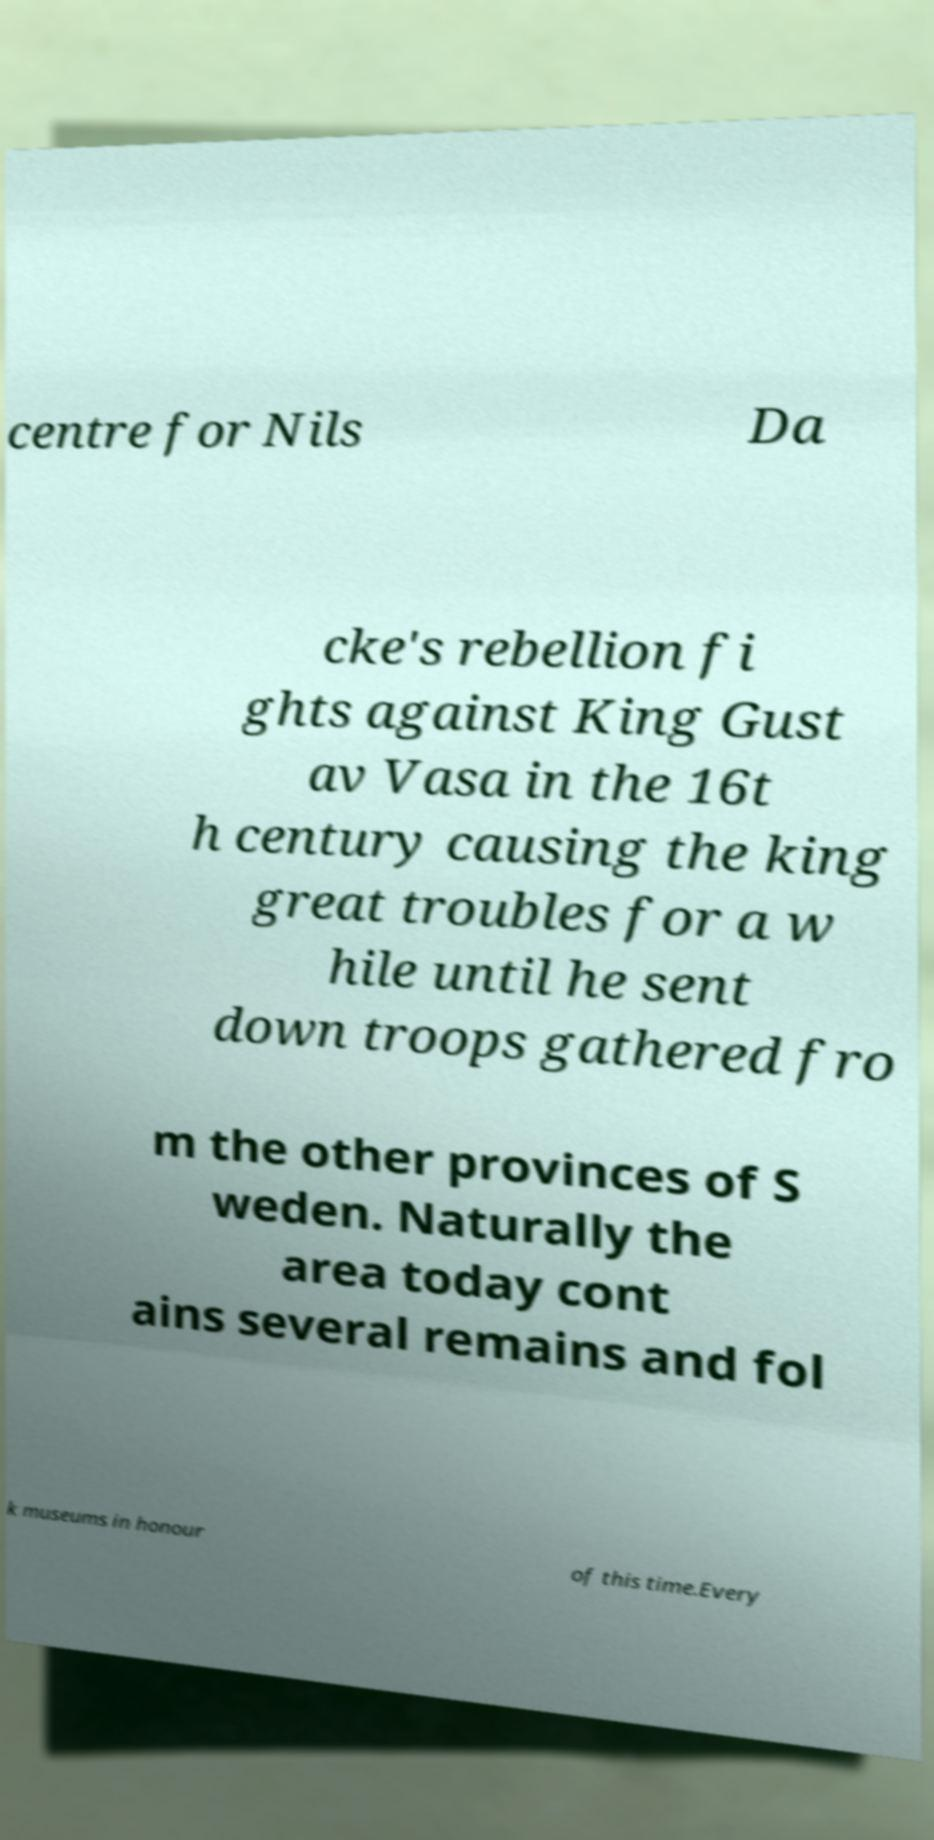There's text embedded in this image that I need extracted. Can you transcribe it verbatim? centre for Nils Da cke's rebellion fi ghts against King Gust av Vasa in the 16t h century causing the king great troubles for a w hile until he sent down troops gathered fro m the other provinces of S weden. Naturally the area today cont ains several remains and fol k museums in honour of this time.Every 